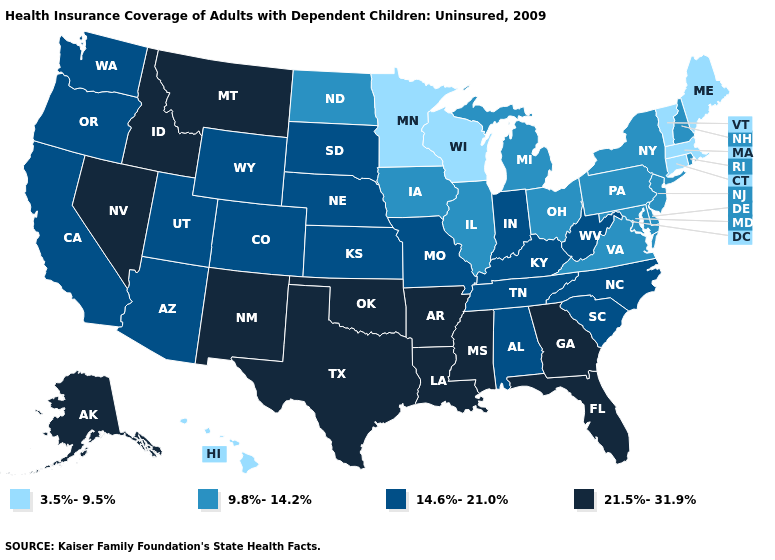How many symbols are there in the legend?
Be succinct. 4. How many symbols are there in the legend?
Keep it brief. 4. Which states have the lowest value in the USA?
Keep it brief. Connecticut, Hawaii, Maine, Massachusetts, Minnesota, Vermont, Wisconsin. What is the lowest value in the USA?
Give a very brief answer. 3.5%-9.5%. Name the states that have a value in the range 14.6%-21.0%?
Quick response, please. Alabama, Arizona, California, Colorado, Indiana, Kansas, Kentucky, Missouri, Nebraska, North Carolina, Oregon, South Carolina, South Dakota, Tennessee, Utah, Washington, West Virginia, Wyoming. What is the value of Massachusetts?
Short answer required. 3.5%-9.5%. What is the value of New Mexico?
Keep it brief. 21.5%-31.9%. What is the value of Arizona?
Write a very short answer. 14.6%-21.0%. Name the states that have a value in the range 21.5%-31.9%?
Concise answer only. Alaska, Arkansas, Florida, Georgia, Idaho, Louisiana, Mississippi, Montana, Nevada, New Mexico, Oklahoma, Texas. Among the states that border Massachusetts , does New York have the lowest value?
Quick response, please. No. What is the value of West Virginia?
Keep it brief. 14.6%-21.0%. How many symbols are there in the legend?
Be succinct. 4. Does Pennsylvania have the same value as Missouri?
Write a very short answer. No. Name the states that have a value in the range 21.5%-31.9%?
Give a very brief answer. Alaska, Arkansas, Florida, Georgia, Idaho, Louisiana, Mississippi, Montana, Nevada, New Mexico, Oklahoma, Texas. Name the states that have a value in the range 9.8%-14.2%?
Keep it brief. Delaware, Illinois, Iowa, Maryland, Michigan, New Hampshire, New Jersey, New York, North Dakota, Ohio, Pennsylvania, Rhode Island, Virginia. 